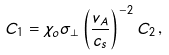<formula> <loc_0><loc_0><loc_500><loc_500>C _ { 1 } = \chi _ { o } \sigma _ { \perp } \left ( \frac { v _ { A } } { c _ { s } } \right ) ^ { - 2 } C _ { 2 } \, ,</formula> 